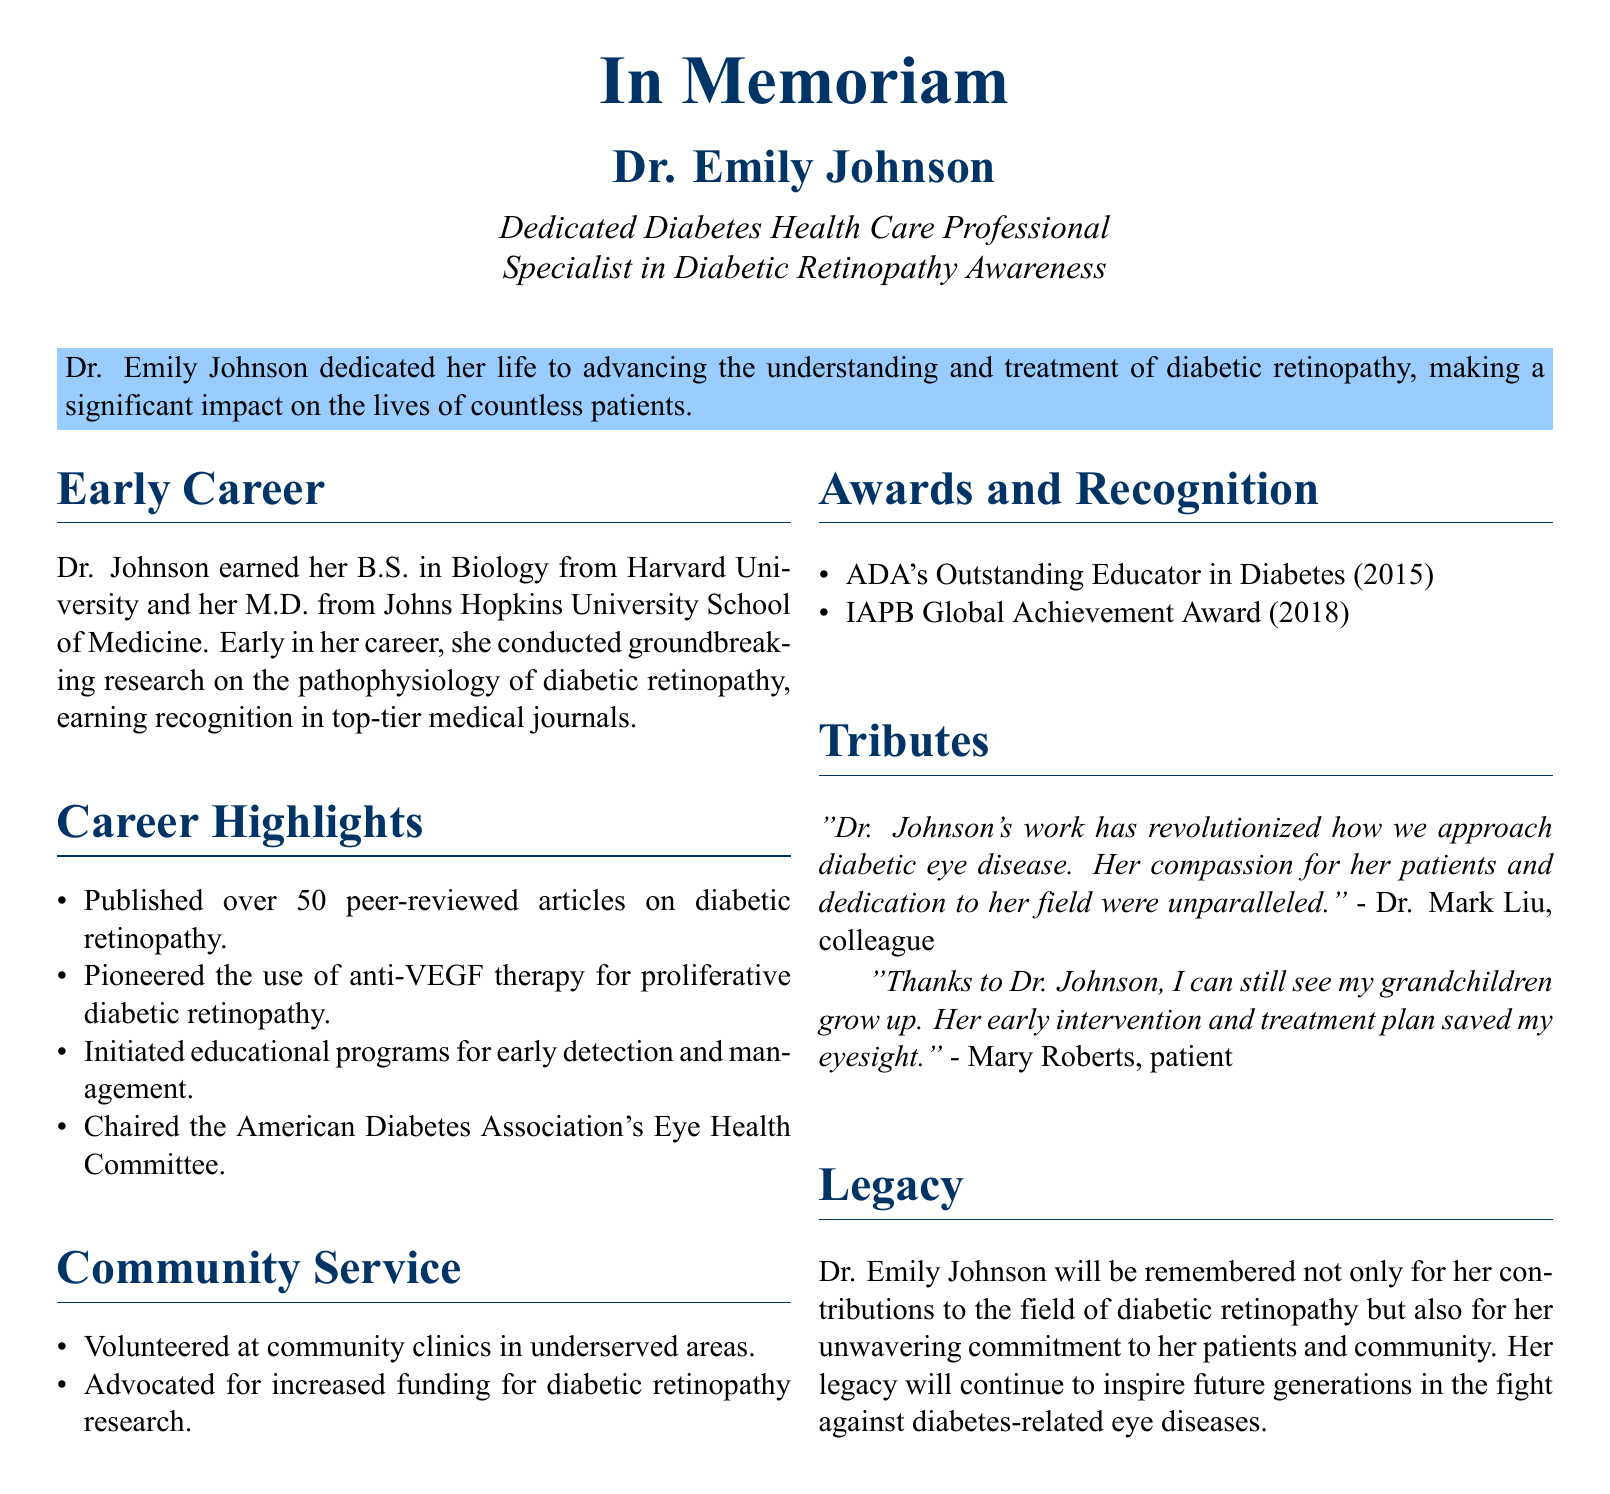What was Dr. Emily Johnson's profession? The document states that she was a dedicated diabetes health care professional and a specialist in diabetic retinopathy awareness.
Answer: diabetes health care professional Where did Dr. Johnson earn her M.D.? The text specifies that she obtained her M.D. from Johns Hopkins University School of Medicine.
Answer: Johns Hopkins University School of Medicine How many peer-reviewed articles did Dr. Johnson publish? The document mentions that she published over 50 peer-reviewed articles on diabetic retinopathy.
Answer: over 50 What award did Dr. Johnson receive in 2015? According to the document, she received the ADA's Outstanding Educator in Diabetes award in that year.
Answer: ADA's Outstanding Educator in Diabetes Who chaired the American Diabetes Association's Eye Health Committee? The obituary notes that Dr. Emily Johnson chaired the Eye Health Committee.
Answer: Dr. Emily Johnson What was one major contribution Dr. Johnson made to diabetic retinopathy treatment? The text highlights that she pioneered the use of anti-VEGF therapy for proliferative diabetic retinopathy.
Answer: anti-VEGF therapy In what year did Dr. Johnson receive the IAPB Global Achievement Award? The document specifies that she received this award in 2018.
Answer: 2018 What did Dr. Mark Liu say about Dr. Johnson's work? The document features Dr. Liu's tribute stating that her work revolutionized the approach to diabetic eye disease.
Answer: revolutionized how we approach diabetic eye disease What impact did Dr. Johnson have on her patients, according to Mary Roberts? The patient, Mary Roberts, stated that Dr. Johnson's intervention saved her eyesight.
Answer: saved my eyesight 